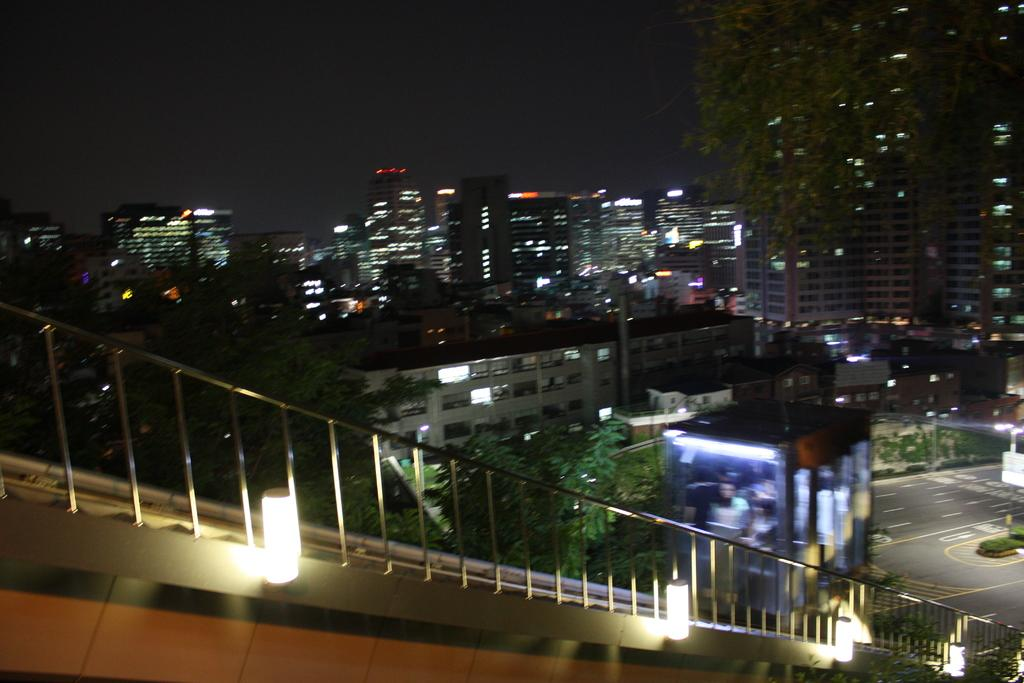What can be seen in the image that provides illumination? There are lights in the image. What type of structure is present in the image? There is railing in the image. What can be seen in the background of the image? There are trees and buildings in the background of the image. What is the color of the trees in the image? The trees are green in color. What is the color of the sky in the image? The sky is black in color. What grade did the person receive for their lunch in the image? There is no lunch or grade present in the image. What type of knowledge can be gained from the image? The image does not convey any specific knowledge or information beyond the visual elements described in the facts. 